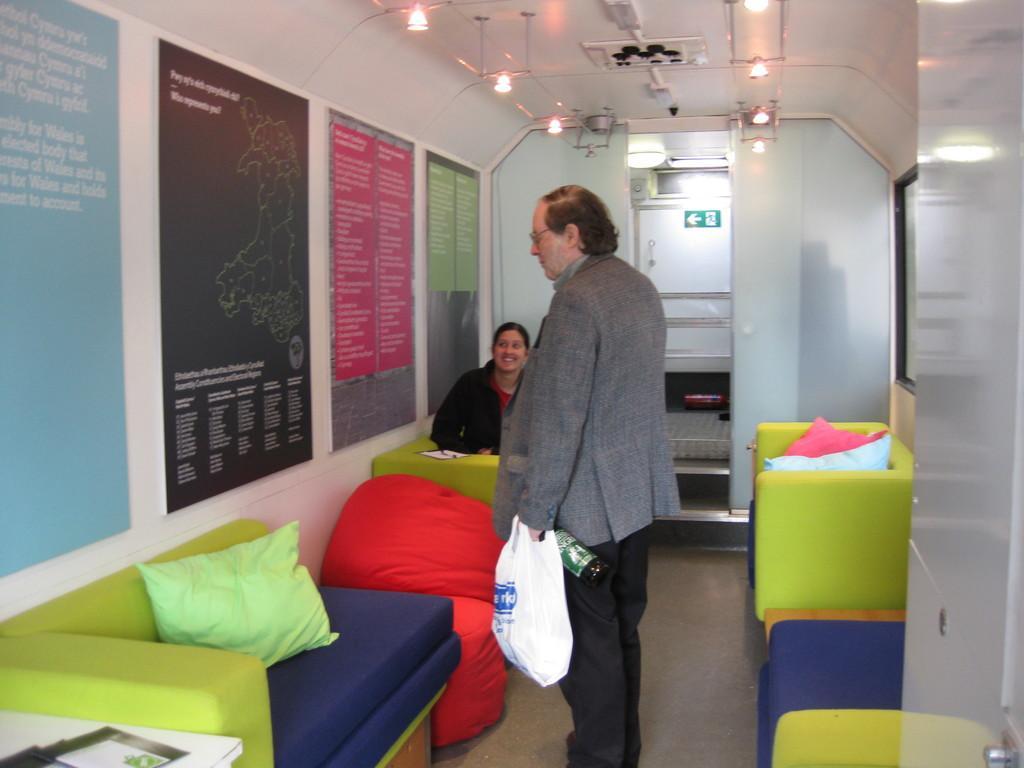Describe this image in one or two sentences. On wall there are different type of posters. This are couches with pillows. This is a bean bag. This man is standing and holds a plastic cover and bottle. This woman is sitting. This is a sign board. Lights are attached to this roof top. 